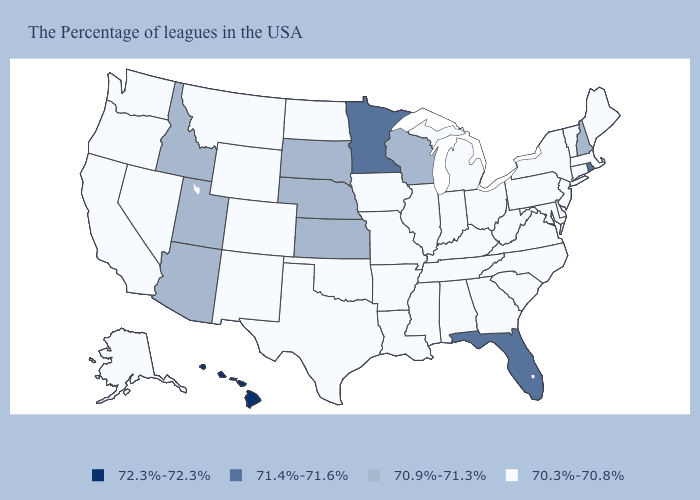Which states hav the highest value in the West?
Short answer required. Hawaii. Among the states that border Nevada , does California have the lowest value?
Write a very short answer. Yes. Among the states that border South Dakota , does Minnesota have the highest value?
Quick response, please. Yes. What is the value of South Dakota?
Be succinct. 70.9%-71.3%. Among the states that border Texas , which have the lowest value?
Write a very short answer. Louisiana, Arkansas, Oklahoma, New Mexico. What is the value of Tennessee?
Be succinct. 70.3%-70.8%. Does West Virginia have a higher value than Alabama?
Short answer required. No. Is the legend a continuous bar?
Give a very brief answer. No. Among the states that border California , does Arizona have the highest value?
Quick response, please. Yes. What is the lowest value in the USA?
Be succinct. 70.3%-70.8%. Which states have the lowest value in the USA?
Keep it brief. Maine, Massachusetts, Vermont, Connecticut, New York, New Jersey, Delaware, Maryland, Pennsylvania, Virginia, North Carolina, South Carolina, West Virginia, Ohio, Georgia, Michigan, Kentucky, Indiana, Alabama, Tennessee, Illinois, Mississippi, Louisiana, Missouri, Arkansas, Iowa, Oklahoma, Texas, North Dakota, Wyoming, Colorado, New Mexico, Montana, Nevada, California, Washington, Oregon, Alaska. Name the states that have a value in the range 70.9%-71.3%?
Short answer required. New Hampshire, Wisconsin, Kansas, Nebraska, South Dakota, Utah, Arizona, Idaho. Which states have the lowest value in the MidWest?
Concise answer only. Ohio, Michigan, Indiana, Illinois, Missouri, Iowa, North Dakota. What is the value of New York?
Concise answer only. 70.3%-70.8%. 